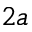<formula> <loc_0><loc_0><loc_500><loc_500>2 a</formula> 